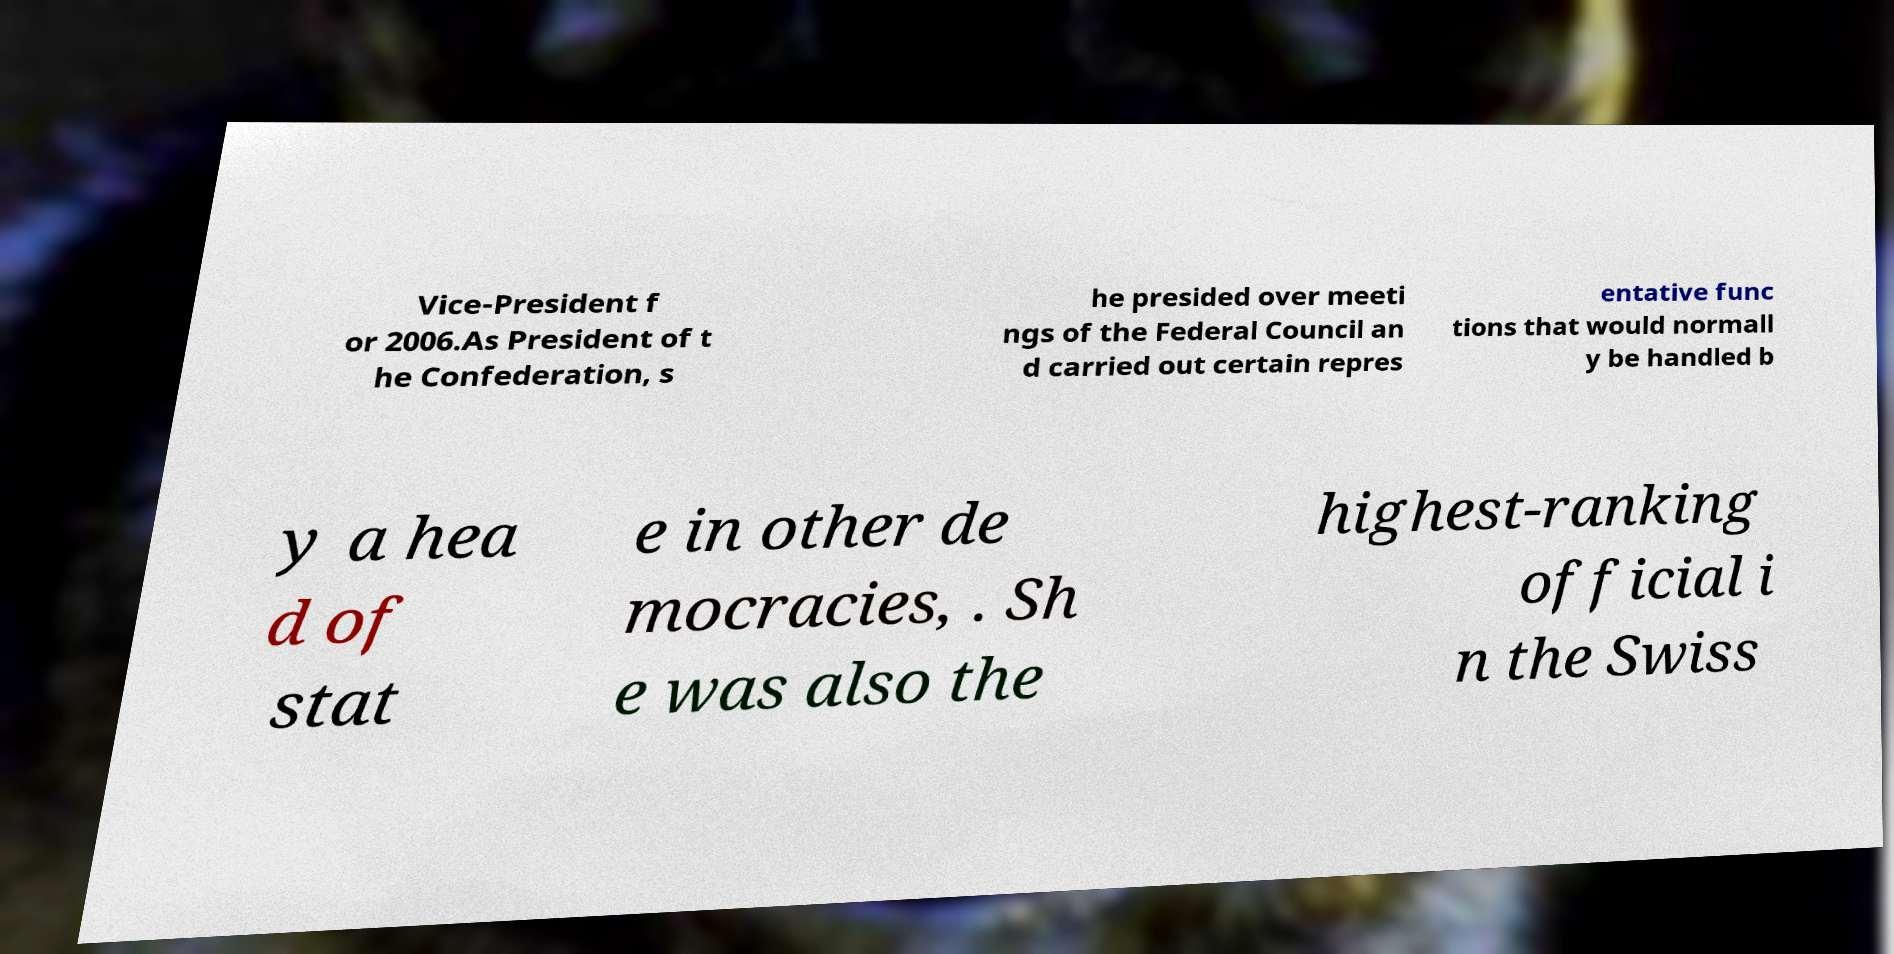Could you extract and type out the text from this image? Vice-President f or 2006.As President of t he Confederation, s he presided over meeti ngs of the Federal Council an d carried out certain repres entative func tions that would normall y be handled b y a hea d of stat e in other de mocracies, . Sh e was also the highest-ranking official i n the Swiss 